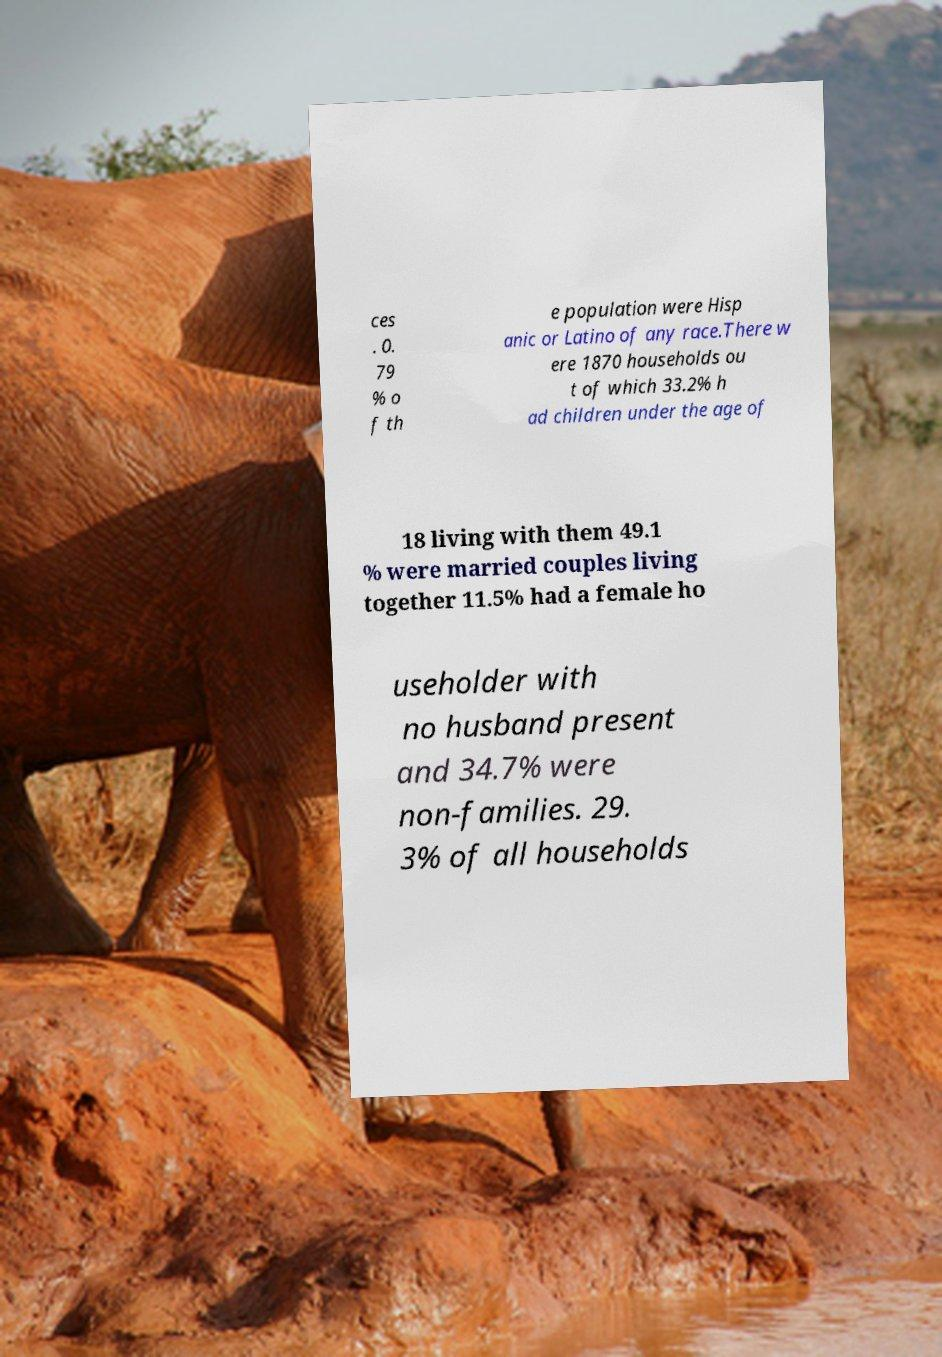For documentation purposes, I need the text within this image transcribed. Could you provide that? ces . 0. 79 % o f th e population were Hisp anic or Latino of any race.There w ere 1870 households ou t of which 33.2% h ad children under the age of 18 living with them 49.1 % were married couples living together 11.5% had a female ho useholder with no husband present and 34.7% were non-families. 29. 3% of all households 